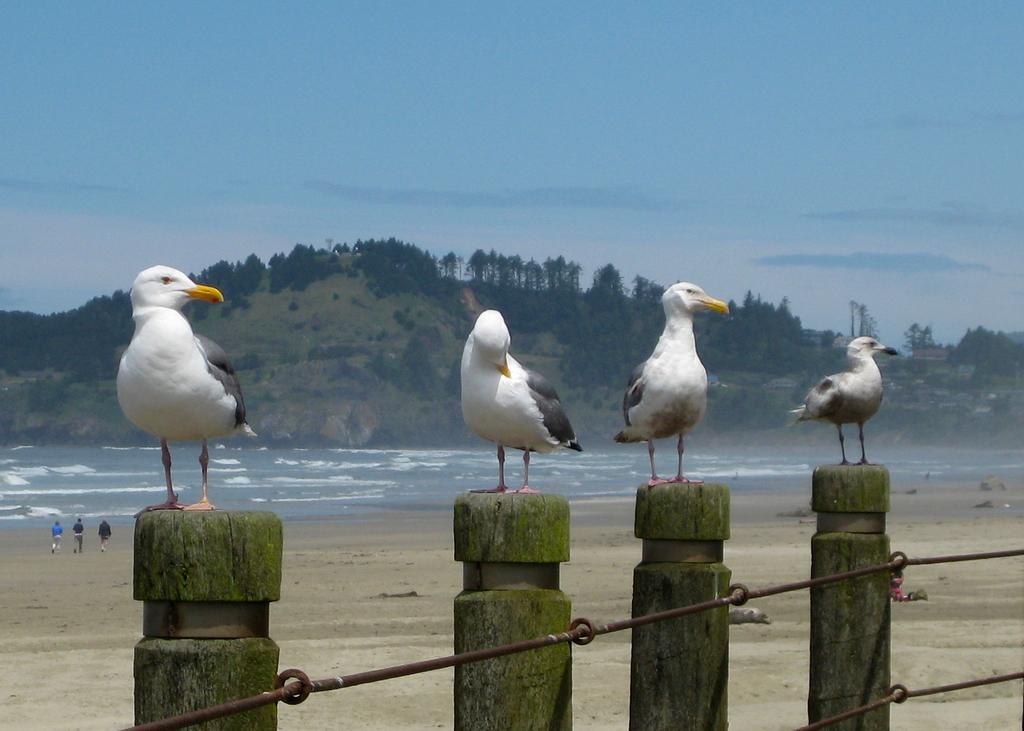Could you give a brief overview of what you see in this image? In this image we can see few birds on the wooden logs. To the wooden logs there are few objects. Behind the birds we can see the water and mountains. On the mountains we can see a group of trees. At the top we can see the sky. On the left side, we can see three persons. 